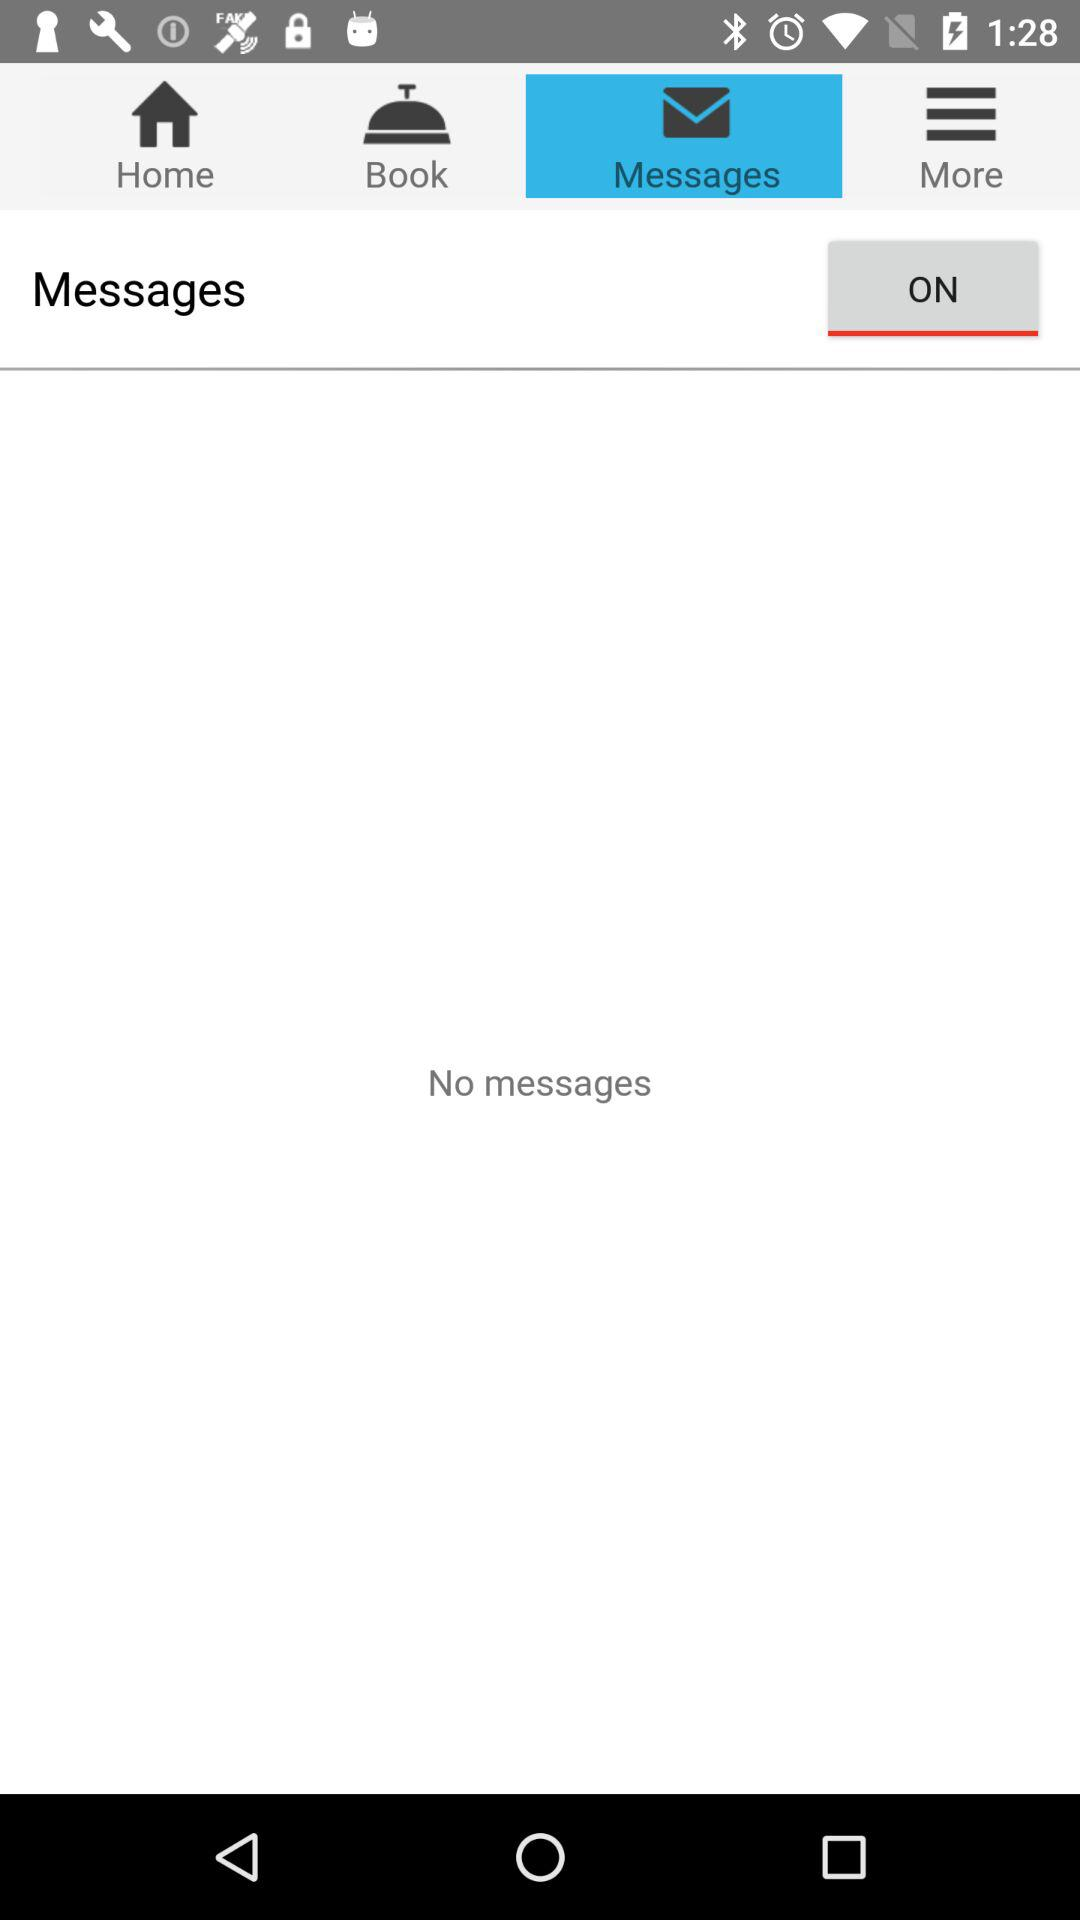How many past bookings are there?
When the provided information is insufficient, respond with <no answer>. <no answer> 